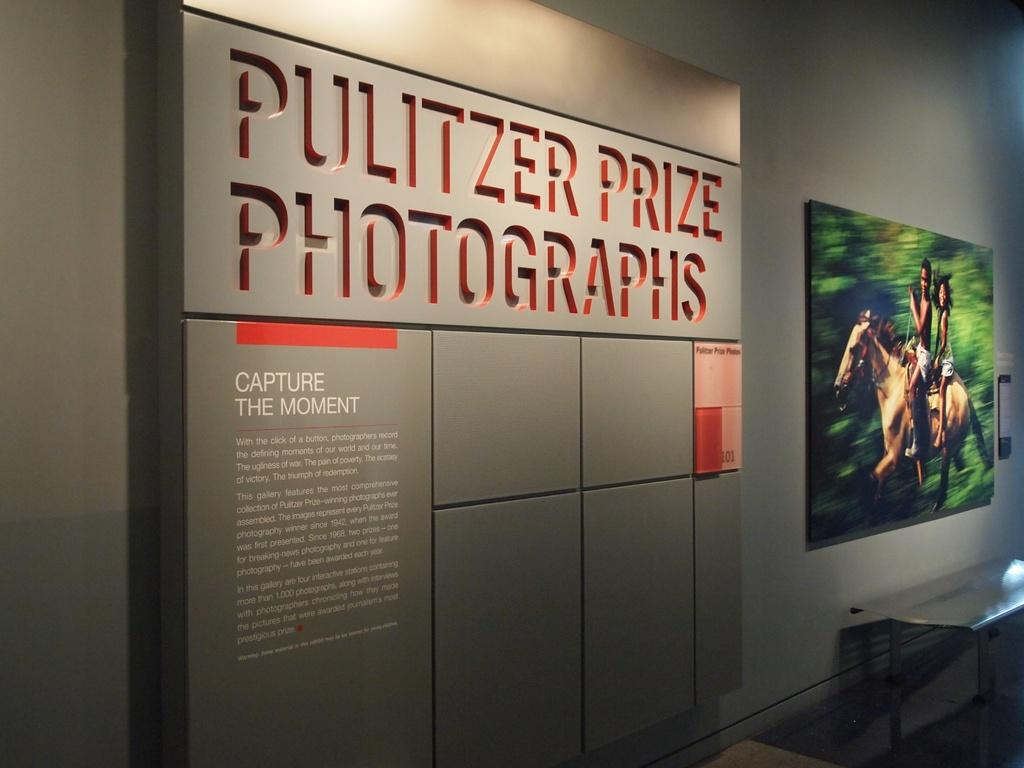What object is located on the right side of the image? There is a photo frame on the right side of the image. What can be seen in the middle of the image? There is something written in the middle of the image. What type of vessel is being used by the maid in the image? There is no vessel or maid present in the image. What advice does the father give to his child in the image? There is no father or child present in the image, and therefore no advice can be observed. 